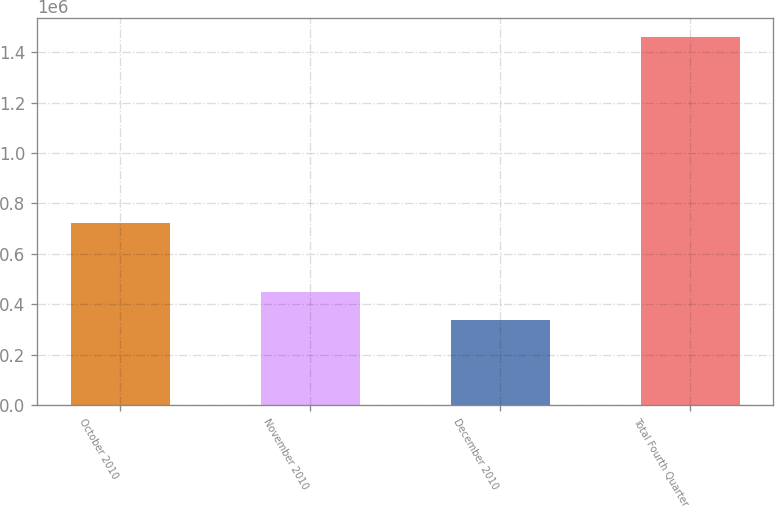<chart> <loc_0><loc_0><loc_500><loc_500><bar_chart><fcel>October 2010<fcel>November 2010<fcel>December 2010<fcel>Total Fourth Quarter<nl><fcel>722890<fcel>449458<fcel>337100<fcel>1.46068e+06<nl></chart> 